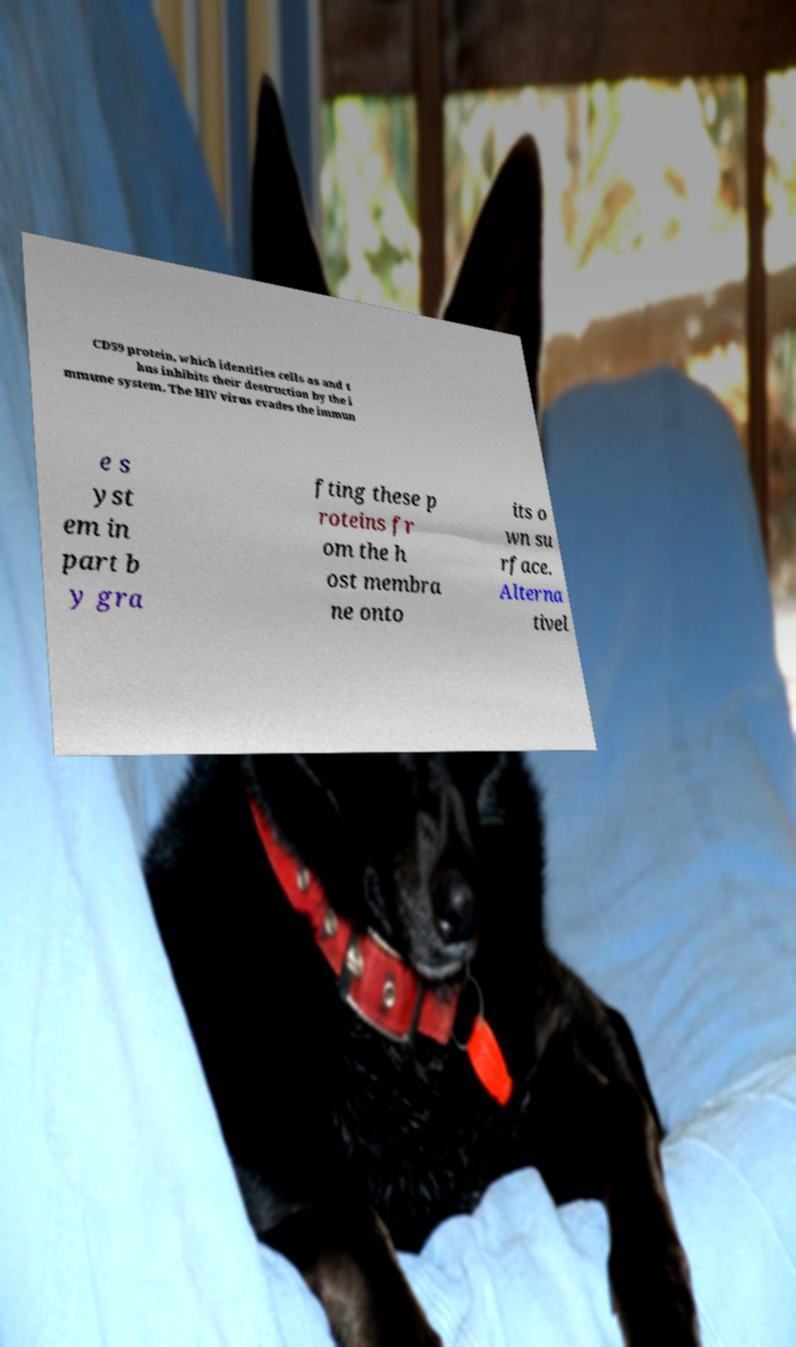Please read and relay the text visible in this image. What does it say? CD59 protein, which identifies cells as and t hus inhibits their destruction by the i mmune system. The HIV virus evades the immun e s yst em in part b y gra fting these p roteins fr om the h ost membra ne onto its o wn su rface. Alterna tivel 